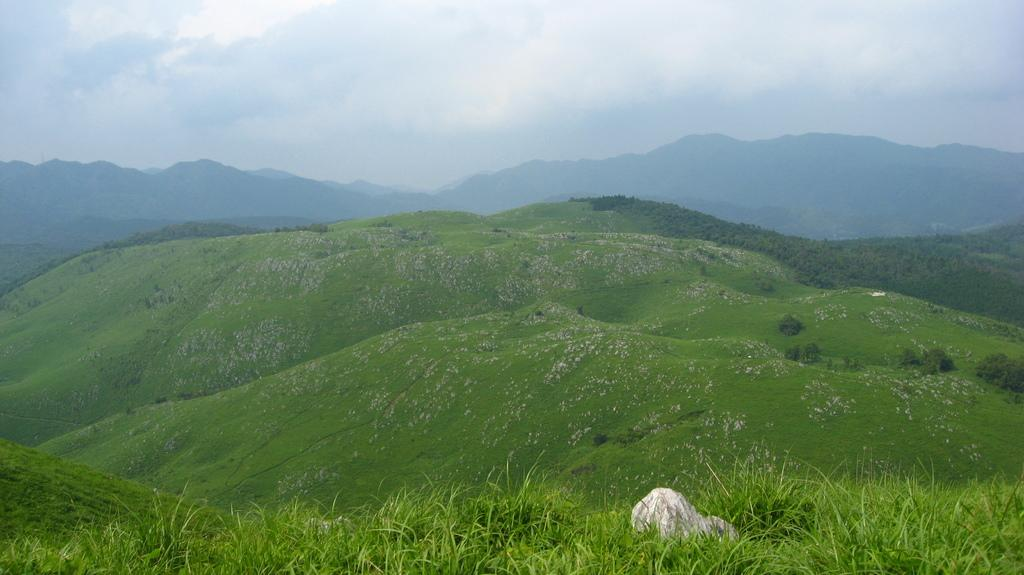What type of terrain is visible in the image? There are hills in the image. What is covering the hills? There is grass on the hills. What can be seen in the background of the image? There are plants and mountains in the background of the image. What is visible at the top of the image? The sky is visible at the top of the image. Where is the cemetery located in the image? There is no cemetery present in the image. What type of education is being provided in the image? There is no indication of any educational activity in the image. 